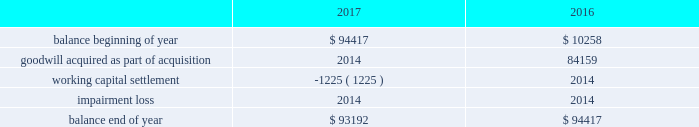Note 4 - goodwill and other intangible assets : goodwill the company had approximately $ 93.2 million and $ 94.4 million of goodwill at december 30 , 2017 and december 31 , 2016 , respectively .
The changes in the carrying amount of goodwill for the years ended december 30 , 2017 and december 31 , 2016 are as follows ( in thousands ) : .
Goodwill is allocated to each identified reporting unit , which is defined as an operating segment or one level below the operating segment .
Goodwill is not amortized , but is evaluated for impairment annually and whenever events or changes in circumstances indicate the carrying value of goodwill may not be recoverable .
The company completes its impairment evaluation by performing valuation analyses and considering other publicly available market information , as appropriate .
The test used to identify the potential for goodwill impairment compares the fair value of a reporting unit with its carrying value .
An impairment charge would be recorded to the company 2019s operations for the amount , if any , in which the carrying value exceeds the fair value .
In the fourth quarter of fiscal 2017 , the company completed its annual impairment testing of goodwill and no impairment was identified .
The company determined that the fair value of each reporting unit ( including goodwill ) was in excess of the carrying value of the respective reporting unit .
In reaching this conclusion , the fair value of each reporting unit was determined based on either a market or an income approach .
Under the market approach , the fair value is based on observed market data .
Other intangible assets the company had approximately $ 31.3 million of intangible assets other than goodwill at december 30 , 2017 and december 31 , 2016 .
The intangible asset balance represents the estimated fair value of the petsense tradename , which is not subject to amortization as it has an indefinite useful life on the basis that it is expected to contribute cash flows beyond the foreseeable horizon .
With respect to intangible assets , we evaluate for impairment annually and whenever events or changes in circumstances indicate that the carrying value may not be recoverable .
We recognize an impairment loss only if the carrying amount is not recoverable through its discounted cash flows and measure the impairment loss based on the difference between the carrying value and fair value .
In the fourth quarter of fiscal 2017 , the company completed its annual impairment testing of intangible assets and no impairment was identified. .
What percent did the company's goodwill balance increase between the between the beginning of 2016 and the end of 2017? 
Computations: ((93192 - 10258) / 10258)
Answer: 8.08481. 